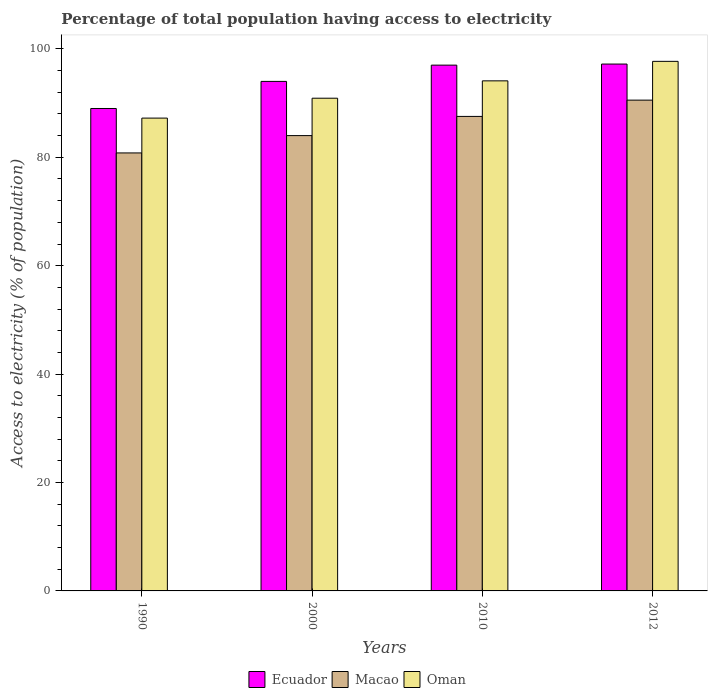How many different coloured bars are there?
Offer a very short reply. 3. Are the number of bars per tick equal to the number of legend labels?
Your answer should be very brief. Yes. How many bars are there on the 1st tick from the left?
Offer a very short reply. 3. How many bars are there on the 3rd tick from the right?
Your answer should be very brief. 3. What is the label of the 1st group of bars from the left?
Make the answer very short. 1990. What is the percentage of population that have access to electricity in Ecuador in 2000?
Your answer should be very brief. 94. Across all years, what is the maximum percentage of population that have access to electricity in Ecuador?
Ensure brevity in your answer.  97.2. Across all years, what is the minimum percentage of population that have access to electricity in Macao?
Ensure brevity in your answer.  80.8. In which year was the percentage of population that have access to electricity in Ecuador maximum?
Offer a very short reply. 2012. What is the total percentage of population that have access to electricity in Oman in the graph?
Provide a short and direct response. 369.92. What is the difference between the percentage of population that have access to electricity in Oman in 2010 and that in 2012?
Give a very brief answer. -3.6. What is the difference between the percentage of population that have access to electricity in Oman in 2000 and the percentage of population that have access to electricity in Macao in 2012?
Give a very brief answer. 0.36. What is the average percentage of population that have access to electricity in Ecuador per year?
Offer a very short reply. 94.3. In the year 2000, what is the difference between the percentage of population that have access to electricity in Oman and percentage of population that have access to electricity in Macao?
Your answer should be compact. 6.9. What is the ratio of the percentage of population that have access to electricity in Oman in 1990 to that in 2000?
Offer a very short reply. 0.96. What is the difference between the highest and the second highest percentage of population that have access to electricity in Macao?
Offer a terse response. 3. What is the difference between the highest and the lowest percentage of population that have access to electricity in Ecuador?
Keep it short and to the point. 8.2. Is the sum of the percentage of population that have access to electricity in Ecuador in 1990 and 2012 greater than the maximum percentage of population that have access to electricity in Macao across all years?
Your response must be concise. Yes. What does the 3rd bar from the left in 2012 represents?
Give a very brief answer. Oman. What does the 2nd bar from the right in 2000 represents?
Keep it short and to the point. Macao. How many years are there in the graph?
Your answer should be very brief. 4. Are the values on the major ticks of Y-axis written in scientific E-notation?
Make the answer very short. No. Does the graph contain any zero values?
Your answer should be very brief. No. How are the legend labels stacked?
Offer a terse response. Horizontal. What is the title of the graph?
Your answer should be very brief. Percentage of total population having access to electricity. What is the label or title of the X-axis?
Offer a very short reply. Years. What is the label or title of the Y-axis?
Keep it short and to the point. Access to electricity (% of population). What is the Access to electricity (% of population) in Ecuador in 1990?
Keep it short and to the point. 89. What is the Access to electricity (% of population) in Macao in 1990?
Ensure brevity in your answer.  80.8. What is the Access to electricity (% of population) in Oman in 1990?
Offer a terse response. 87.23. What is the Access to electricity (% of population) in Ecuador in 2000?
Keep it short and to the point. 94. What is the Access to electricity (% of population) of Macao in 2000?
Your answer should be compact. 84. What is the Access to electricity (% of population) in Oman in 2000?
Offer a very short reply. 90.9. What is the Access to electricity (% of population) in Ecuador in 2010?
Provide a short and direct response. 97. What is the Access to electricity (% of population) in Macao in 2010?
Keep it short and to the point. 87.54. What is the Access to electricity (% of population) in Oman in 2010?
Your answer should be compact. 94.1. What is the Access to electricity (% of population) in Ecuador in 2012?
Make the answer very short. 97.2. What is the Access to electricity (% of population) of Macao in 2012?
Offer a terse response. 90.54. What is the Access to electricity (% of population) in Oman in 2012?
Give a very brief answer. 97.7. Across all years, what is the maximum Access to electricity (% of population) in Ecuador?
Offer a terse response. 97.2. Across all years, what is the maximum Access to electricity (% of population) of Macao?
Keep it short and to the point. 90.54. Across all years, what is the maximum Access to electricity (% of population) in Oman?
Your answer should be very brief. 97.7. Across all years, what is the minimum Access to electricity (% of population) in Ecuador?
Provide a succinct answer. 89. Across all years, what is the minimum Access to electricity (% of population) in Macao?
Your response must be concise. 80.8. Across all years, what is the minimum Access to electricity (% of population) in Oman?
Offer a terse response. 87.23. What is the total Access to electricity (% of population) in Ecuador in the graph?
Ensure brevity in your answer.  377.2. What is the total Access to electricity (% of population) of Macao in the graph?
Your answer should be very brief. 342.89. What is the total Access to electricity (% of population) of Oman in the graph?
Your response must be concise. 369.92. What is the difference between the Access to electricity (% of population) of Ecuador in 1990 and that in 2000?
Your answer should be very brief. -5. What is the difference between the Access to electricity (% of population) in Macao in 1990 and that in 2000?
Your answer should be very brief. -3.2. What is the difference between the Access to electricity (% of population) of Oman in 1990 and that in 2000?
Your answer should be very brief. -3.67. What is the difference between the Access to electricity (% of population) in Macao in 1990 and that in 2010?
Provide a succinct answer. -6.74. What is the difference between the Access to electricity (% of population) of Oman in 1990 and that in 2010?
Your answer should be compact. -6.87. What is the difference between the Access to electricity (% of population) of Ecuador in 1990 and that in 2012?
Offer a very short reply. -8.2. What is the difference between the Access to electricity (% of population) of Macao in 1990 and that in 2012?
Your answer should be compact. -9.74. What is the difference between the Access to electricity (% of population) in Oman in 1990 and that in 2012?
Your response must be concise. -10.47. What is the difference between the Access to electricity (% of population) of Ecuador in 2000 and that in 2010?
Your response must be concise. -3. What is the difference between the Access to electricity (% of population) in Macao in 2000 and that in 2010?
Your answer should be compact. -3.54. What is the difference between the Access to electricity (% of population) of Oman in 2000 and that in 2010?
Your answer should be very brief. -3.2. What is the difference between the Access to electricity (% of population) of Macao in 2000 and that in 2012?
Your response must be concise. -6.54. What is the difference between the Access to electricity (% of population) in Oman in 2000 and that in 2012?
Your answer should be very brief. -6.8. What is the difference between the Access to electricity (% of population) in Macao in 2010 and that in 2012?
Give a very brief answer. -3. What is the difference between the Access to electricity (% of population) in Oman in 2010 and that in 2012?
Provide a short and direct response. -3.6. What is the difference between the Access to electricity (% of population) in Ecuador in 1990 and the Access to electricity (% of population) in Oman in 2000?
Your answer should be very brief. -1.9. What is the difference between the Access to electricity (% of population) of Macao in 1990 and the Access to electricity (% of population) of Oman in 2000?
Provide a short and direct response. -10.1. What is the difference between the Access to electricity (% of population) of Ecuador in 1990 and the Access to electricity (% of population) of Macao in 2010?
Offer a very short reply. 1.46. What is the difference between the Access to electricity (% of population) in Macao in 1990 and the Access to electricity (% of population) in Oman in 2010?
Your answer should be compact. -13.3. What is the difference between the Access to electricity (% of population) of Ecuador in 1990 and the Access to electricity (% of population) of Macao in 2012?
Offer a very short reply. -1.54. What is the difference between the Access to electricity (% of population) in Ecuador in 1990 and the Access to electricity (% of population) in Oman in 2012?
Ensure brevity in your answer.  -8.7. What is the difference between the Access to electricity (% of population) in Macao in 1990 and the Access to electricity (% of population) in Oman in 2012?
Provide a short and direct response. -16.89. What is the difference between the Access to electricity (% of population) in Ecuador in 2000 and the Access to electricity (% of population) in Macao in 2010?
Your answer should be compact. 6.46. What is the difference between the Access to electricity (% of population) in Ecuador in 2000 and the Access to electricity (% of population) in Macao in 2012?
Give a very brief answer. 3.46. What is the difference between the Access to electricity (% of population) in Ecuador in 2000 and the Access to electricity (% of population) in Oman in 2012?
Your response must be concise. -3.7. What is the difference between the Access to electricity (% of population) of Macao in 2000 and the Access to electricity (% of population) of Oman in 2012?
Offer a very short reply. -13.7. What is the difference between the Access to electricity (% of population) in Ecuador in 2010 and the Access to electricity (% of population) in Macao in 2012?
Your answer should be very brief. 6.46. What is the difference between the Access to electricity (% of population) of Ecuador in 2010 and the Access to electricity (% of population) of Oman in 2012?
Offer a very short reply. -0.7. What is the difference between the Access to electricity (% of population) of Macao in 2010 and the Access to electricity (% of population) of Oman in 2012?
Your answer should be compact. -10.16. What is the average Access to electricity (% of population) in Ecuador per year?
Offer a very short reply. 94.3. What is the average Access to electricity (% of population) in Macao per year?
Offer a terse response. 85.72. What is the average Access to electricity (% of population) in Oman per year?
Offer a very short reply. 92.48. In the year 1990, what is the difference between the Access to electricity (% of population) in Ecuador and Access to electricity (% of population) in Macao?
Give a very brief answer. 8.2. In the year 1990, what is the difference between the Access to electricity (% of population) of Ecuador and Access to electricity (% of population) of Oman?
Offer a terse response. 1.77. In the year 1990, what is the difference between the Access to electricity (% of population) in Macao and Access to electricity (% of population) in Oman?
Offer a very short reply. -6.42. In the year 2000, what is the difference between the Access to electricity (% of population) of Ecuador and Access to electricity (% of population) of Oman?
Give a very brief answer. 3.1. In the year 2000, what is the difference between the Access to electricity (% of population) of Macao and Access to electricity (% of population) of Oman?
Provide a succinct answer. -6.9. In the year 2010, what is the difference between the Access to electricity (% of population) in Ecuador and Access to electricity (% of population) in Macao?
Offer a terse response. 9.46. In the year 2010, what is the difference between the Access to electricity (% of population) of Macao and Access to electricity (% of population) of Oman?
Give a very brief answer. -6.56. In the year 2012, what is the difference between the Access to electricity (% of population) of Ecuador and Access to electricity (% of population) of Macao?
Keep it short and to the point. 6.66. In the year 2012, what is the difference between the Access to electricity (% of population) in Ecuador and Access to electricity (% of population) in Oman?
Offer a terse response. -0.5. In the year 2012, what is the difference between the Access to electricity (% of population) of Macao and Access to electricity (% of population) of Oman?
Ensure brevity in your answer.  -7.16. What is the ratio of the Access to electricity (% of population) in Ecuador in 1990 to that in 2000?
Keep it short and to the point. 0.95. What is the ratio of the Access to electricity (% of population) in Macao in 1990 to that in 2000?
Make the answer very short. 0.96. What is the ratio of the Access to electricity (% of population) in Oman in 1990 to that in 2000?
Your answer should be very brief. 0.96. What is the ratio of the Access to electricity (% of population) of Ecuador in 1990 to that in 2010?
Provide a succinct answer. 0.92. What is the ratio of the Access to electricity (% of population) of Macao in 1990 to that in 2010?
Ensure brevity in your answer.  0.92. What is the ratio of the Access to electricity (% of population) in Oman in 1990 to that in 2010?
Your response must be concise. 0.93. What is the ratio of the Access to electricity (% of population) in Ecuador in 1990 to that in 2012?
Ensure brevity in your answer.  0.92. What is the ratio of the Access to electricity (% of population) of Macao in 1990 to that in 2012?
Offer a terse response. 0.89. What is the ratio of the Access to electricity (% of population) of Oman in 1990 to that in 2012?
Your response must be concise. 0.89. What is the ratio of the Access to electricity (% of population) in Ecuador in 2000 to that in 2010?
Your answer should be very brief. 0.97. What is the ratio of the Access to electricity (% of population) in Macao in 2000 to that in 2010?
Your answer should be compact. 0.96. What is the ratio of the Access to electricity (% of population) in Ecuador in 2000 to that in 2012?
Offer a very short reply. 0.97. What is the ratio of the Access to electricity (% of population) of Macao in 2000 to that in 2012?
Your answer should be compact. 0.93. What is the ratio of the Access to electricity (% of population) of Oman in 2000 to that in 2012?
Make the answer very short. 0.93. What is the ratio of the Access to electricity (% of population) of Macao in 2010 to that in 2012?
Your answer should be very brief. 0.97. What is the ratio of the Access to electricity (% of population) in Oman in 2010 to that in 2012?
Your answer should be very brief. 0.96. What is the difference between the highest and the second highest Access to electricity (% of population) in Ecuador?
Give a very brief answer. 0.2. What is the difference between the highest and the second highest Access to electricity (% of population) in Macao?
Offer a very short reply. 3. What is the difference between the highest and the second highest Access to electricity (% of population) in Oman?
Ensure brevity in your answer.  3.6. What is the difference between the highest and the lowest Access to electricity (% of population) of Macao?
Ensure brevity in your answer.  9.74. What is the difference between the highest and the lowest Access to electricity (% of population) in Oman?
Provide a succinct answer. 10.47. 